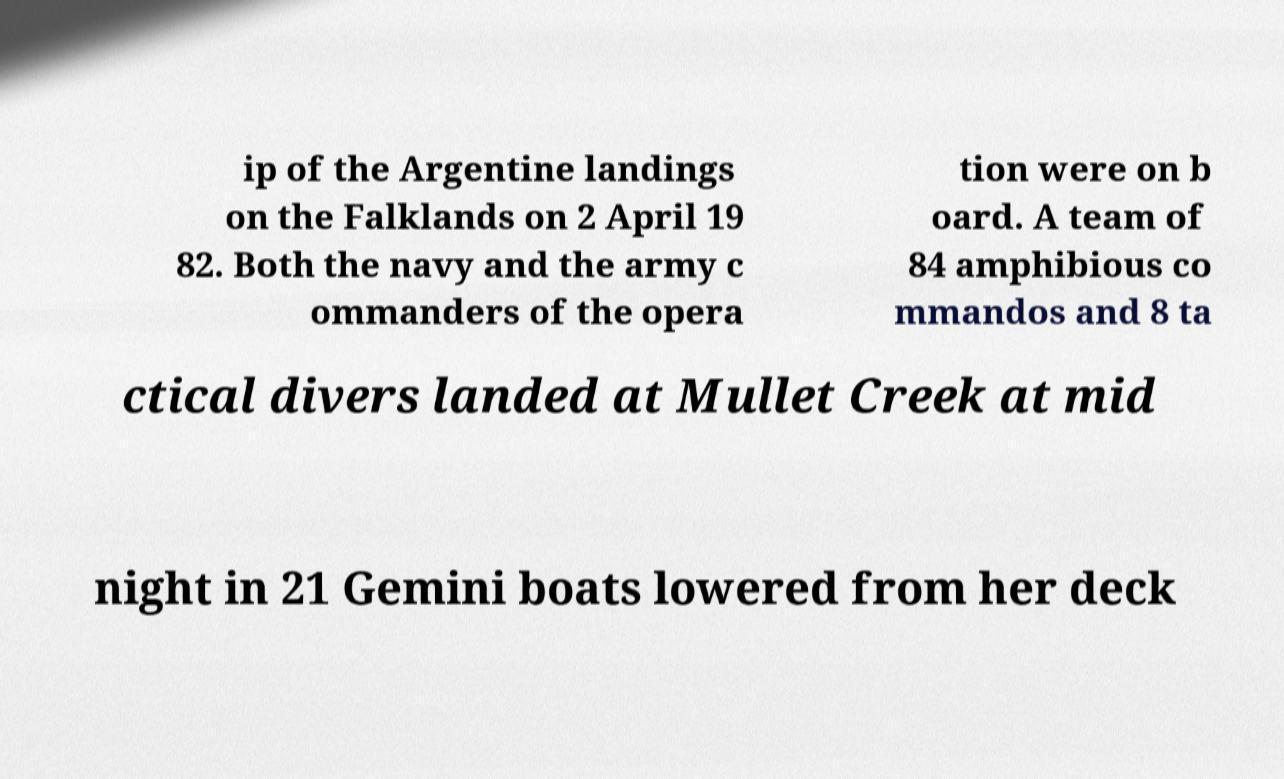Please read and relay the text visible in this image. What does it say? ip of the Argentine landings on the Falklands on 2 April 19 82. Both the navy and the army c ommanders of the opera tion were on b oard. A team of 84 amphibious co mmandos and 8 ta ctical divers landed at Mullet Creek at mid night in 21 Gemini boats lowered from her deck 